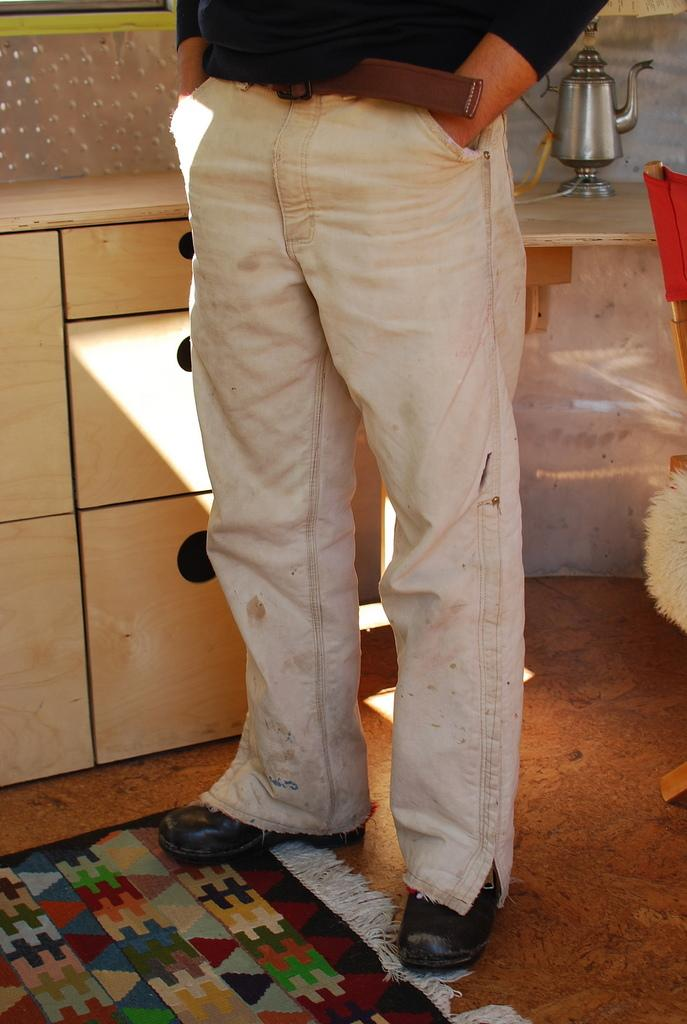What is the main subject of the image? There is a person standing in the image. Where is the person standing? The person is standing on the floor. What objects can be seen in the background of the image? There is a cabinet, a kettle, and a chair in the background of the image. What type of location is suggested by the image? The image is likely taken in a room. What hill can be seen in the background of the image? There is no hill present in the image; it is likely taken in a room with a cabinet, a kettle, and a chair in the background. 